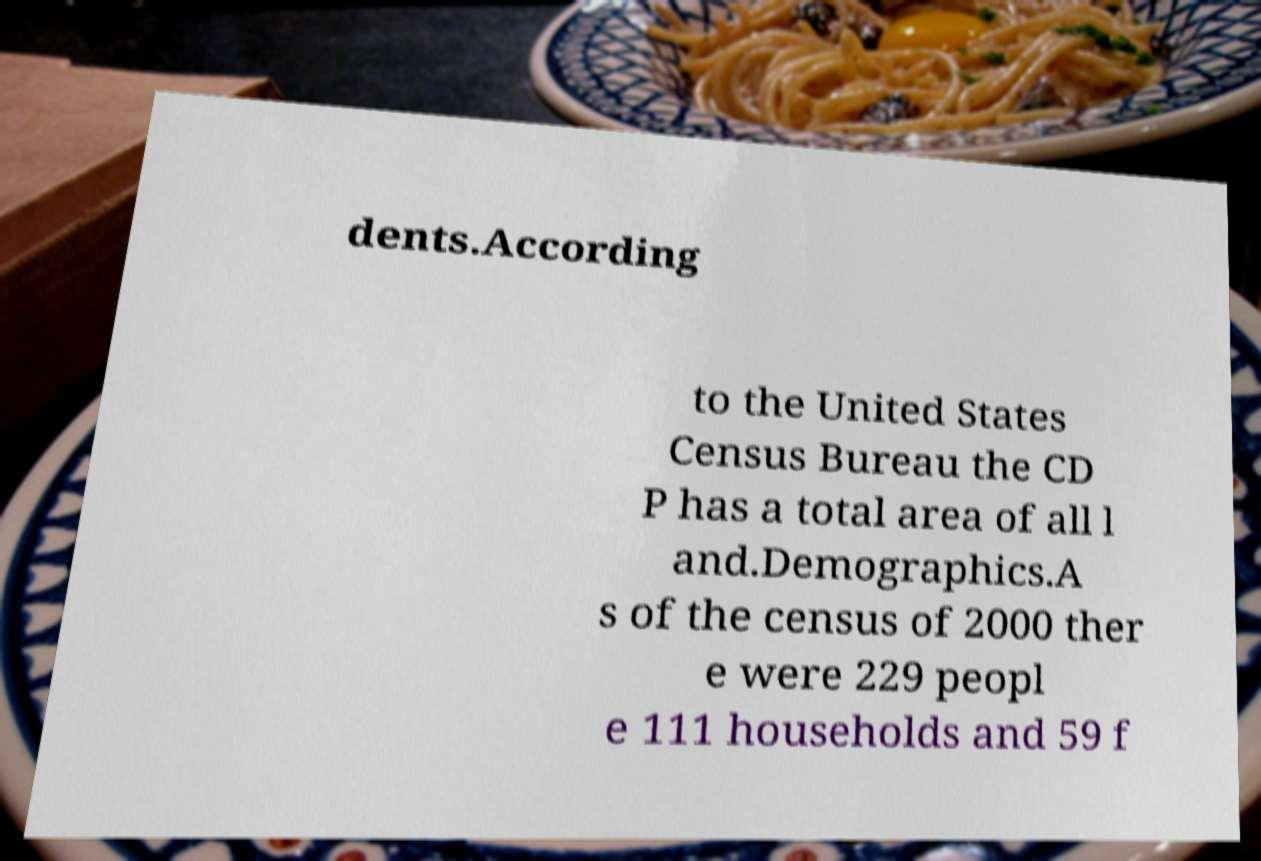Please identify and transcribe the text found in this image. dents.According to the United States Census Bureau the CD P has a total area of all l and.Demographics.A s of the census of 2000 ther e were 229 peopl e 111 households and 59 f 